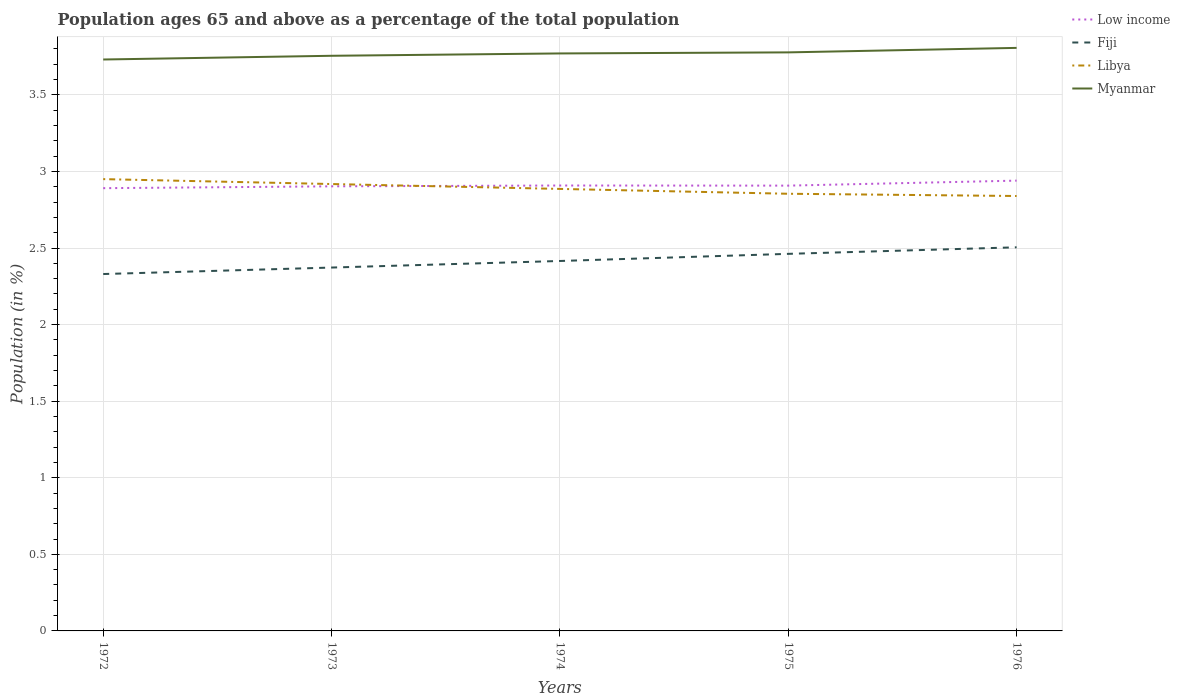How many different coloured lines are there?
Provide a short and direct response. 4. Is the number of lines equal to the number of legend labels?
Offer a terse response. Yes. Across all years, what is the maximum percentage of the population ages 65 and above in Myanmar?
Make the answer very short. 3.73. In which year was the percentage of the population ages 65 and above in Low income maximum?
Offer a very short reply. 1972. What is the total percentage of the population ages 65 and above in Myanmar in the graph?
Your answer should be compact. -0.02. What is the difference between the highest and the second highest percentage of the population ages 65 and above in Low income?
Give a very brief answer. 0.05. Is the percentage of the population ages 65 and above in Libya strictly greater than the percentage of the population ages 65 and above in Myanmar over the years?
Offer a very short reply. Yes. How many lines are there?
Give a very brief answer. 4. What is the difference between two consecutive major ticks on the Y-axis?
Provide a succinct answer. 0.5. Where does the legend appear in the graph?
Your response must be concise. Top right. How are the legend labels stacked?
Provide a short and direct response. Vertical. What is the title of the graph?
Provide a succinct answer. Population ages 65 and above as a percentage of the total population. What is the label or title of the Y-axis?
Offer a very short reply. Population (in %). What is the Population (in %) of Low income in 1972?
Give a very brief answer. 2.89. What is the Population (in %) in Fiji in 1972?
Provide a short and direct response. 2.33. What is the Population (in %) of Libya in 1972?
Offer a terse response. 2.95. What is the Population (in %) of Myanmar in 1972?
Your answer should be compact. 3.73. What is the Population (in %) in Low income in 1973?
Offer a very short reply. 2.9. What is the Population (in %) of Fiji in 1973?
Your response must be concise. 2.37. What is the Population (in %) of Libya in 1973?
Offer a very short reply. 2.92. What is the Population (in %) of Myanmar in 1973?
Provide a succinct answer. 3.76. What is the Population (in %) in Low income in 1974?
Ensure brevity in your answer.  2.91. What is the Population (in %) in Fiji in 1974?
Your answer should be compact. 2.42. What is the Population (in %) of Libya in 1974?
Your response must be concise. 2.89. What is the Population (in %) in Myanmar in 1974?
Offer a terse response. 3.77. What is the Population (in %) in Low income in 1975?
Provide a succinct answer. 2.91. What is the Population (in %) in Fiji in 1975?
Offer a very short reply. 2.46. What is the Population (in %) of Libya in 1975?
Provide a short and direct response. 2.85. What is the Population (in %) in Myanmar in 1975?
Keep it short and to the point. 3.78. What is the Population (in %) in Low income in 1976?
Offer a very short reply. 2.94. What is the Population (in %) in Fiji in 1976?
Your response must be concise. 2.5. What is the Population (in %) in Libya in 1976?
Provide a short and direct response. 2.84. What is the Population (in %) in Myanmar in 1976?
Offer a terse response. 3.81. Across all years, what is the maximum Population (in %) in Low income?
Your answer should be compact. 2.94. Across all years, what is the maximum Population (in %) of Fiji?
Offer a terse response. 2.5. Across all years, what is the maximum Population (in %) of Libya?
Give a very brief answer. 2.95. Across all years, what is the maximum Population (in %) of Myanmar?
Your answer should be compact. 3.81. Across all years, what is the minimum Population (in %) in Low income?
Provide a short and direct response. 2.89. Across all years, what is the minimum Population (in %) in Fiji?
Make the answer very short. 2.33. Across all years, what is the minimum Population (in %) in Libya?
Your answer should be compact. 2.84. Across all years, what is the minimum Population (in %) in Myanmar?
Give a very brief answer. 3.73. What is the total Population (in %) of Low income in the graph?
Make the answer very short. 14.55. What is the total Population (in %) of Fiji in the graph?
Your answer should be very brief. 12.09. What is the total Population (in %) of Libya in the graph?
Give a very brief answer. 14.45. What is the total Population (in %) of Myanmar in the graph?
Provide a short and direct response. 18.84. What is the difference between the Population (in %) in Low income in 1972 and that in 1973?
Offer a terse response. -0.01. What is the difference between the Population (in %) of Fiji in 1972 and that in 1973?
Your answer should be very brief. -0.04. What is the difference between the Population (in %) of Libya in 1972 and that in 1973?
Provide a succinct answer. 0.03. What is the difference between the Population (in %) in Myanmar in 1972 and that in 1973?
Your answer should be very brief. -0.02. What is the difference between the Population (in %) in Low income in 1972 and that in 1974?
Your answer should be compact. -0.02. What is the difference between the Population (in %) in Fiji in 1972 and that in 1974?
Offer a very short reply. -0.09. What is the difference between the Population (in %) of Libya in 1972 and that in 1974?
Make the answer very short. 0.06. What is the difference between the Population (in %) in Myanmar in 1972 and that in 1974?
Your answer should be very brief. -0.04. What is the difference between the Population (in %) in Low income in 1972 and that in 1975?
Your answer should be very brief. -0.02. What is the difference between the Population (in %) in Fiji in 1972 and that in 1975?
Keep it short and to the point. -0.13. What is the difference between the Population (in %) in Libya in 1972 and that in 1975?
Offer a terse response. 0.1. What is the difference between the Population (in %) of Myanmar in 1972 and that in 1975?
Your answer should be very brief. -0.05. What is the difference between the Population (in %) of Low income in 1972 and that in 1976?
Your response must be concise. -0.05. What is the difference between the Population (in %) in Fiji in 1972 and that in 1976?
Your answer should be very brief. -0.17. What is the difference between the Population (in %) of Libya in 1972 and that in 1976?
Provide a succinct answer. 0.11. What is the difference between the Population (in %) in Myanmar in 1972 and that in 1976?
Offer a terse response. -0.08. What is the difference between the Population (in %) of Low income in 1973 and that in 1974?
Make the answer very short. -0.01. What is the difference between the Population (in %) of Fiji in 1973 and that in 1974?
Your response must be concise. -0.04. What is the difference between the Population (in %) in Libya in 1973 and that in 1974?
Offer a very short reply. 0.03. What is the difference between the Population (in %) in Myanmar in 1973 and that in 1974?
Offer a very short reply. -0.02. What is the difference between the Population (in %) in Low income in 1973 and that in 1975?
Offer a very short reply. -0. What is the difference between the Population (in %) in Fiji in 1973 and that in 1975?
Provide a short and direct response. -0.09. What is the difference between the Population (in %) in Libya in 1973 and that in 1975?
Your answer should be compact. 0.06. What is the difference between the Population (in %) in Myanmar in 1973 and that in 1975?
Provide a short and direct response. -0.02. What is the difference between the Population (in %) of Low income in 1973 and that in 1976?
Your answer should be very brief. -0.04. What is the difference between the Population (in %) in Fiji in 1973 and that in 1976?
Your answer should be compact. -0.13. What is the difference between the Population (in %) of Libya in 1973 and that in 1976?
Keep it short and to the point. 0.08. What is the difference between the Population (in %) of Myanmar in 1973 and that in 1976?
Your response must be concise. -0.05. What is the difference between the Population (in %) in Low income in 1974 and that in 1975?
Your answer should be compact. 0. What is the difference between the Population (in %) of Fiji in 1974 and that in 1975?
Provide a short and direct response. -0.05. What is the difference between the Population (in %) in Libya in 1974 and that in 1975?
Provide a short and direct response. 0.03. What is the difference between the Population (in %) in Myanmar in 1974 and that in 1975?
Give a very brief answer. -0.01. What is the difference between the Population (in %) of Low income in 1974 and that in 1976?
Provide a short and direct response. -0.03. What is the difference between the Population (in %) in Fiji in 1974 and that in 1976?
Your answer should be compact. -0.09. What is the difference between the Population (in %) of Libya in 1974 and that in 1976?
Provide a short and direct response. 0.05. What is the difference between the Population (in %) in Myanmar in 1974 and that in 1976?
Your answer should be very brief. -0.04. What is the difference between the Population (in %) of Low income in 1975 and that in 1976?
Offer a terse response. -0.03. What is the difference between the Population (in %) of Fiji in 1975 and that in 1976?
Offer a very short reply. -0.04. What is the difference between the Population (in %) of Libya in 1975 and that in 1976?
Your answer should be very brief. 0.01. What is the difference between the Population (in %) in Myanmar in 1975 and that in 1976?
Your answer should be compact. -0.03. What is the difference between the Population (in %) in Low income in 1972 and the Population (in %) in Fiji in 1973?
Your answer should be very brief. 0.52. What is the difference between the Population (in %) of Low income in 1972 and the Population (in %) of Libya in 1973?
Make the answer very short. -0.03. What is the difference between the Population (in %) in Low income in 1972 and the Population (in %) in Myanmar in 1973?
Give a very brief answer. -0.86. What is the difference between the Population (in %) of Fiji in 1972 and the Population (in %) of Libya in 1973?
Offer a very short reply. -0.59. What is the difference between the Population (in %) in Fiji in 1972 and the Population (in %) in Myanmar in 1973?
Ensure brevity in your answer.  -1.43. What is the difference between the Population (in %) in Libya in 1972 and the Population (in %) in Myanmar in 1973?
Give a very brief answer. -0.81. What is the difference between the Population (in %) of Low income in 1972 and the Population (in %) of Fiji in 1974?
Your answer should be very brief. 0.48. What is the difference between the Population (in %) of Low income in 1972 and the Population (in %) of Libya in 1974?
Make the answer very short. 0. What is the difference between the Population (in %) in Low income in 1972 and the Population (in %) in Myanmar in 1974?
Provide a succinct answer. -0.88. What is the difference between the Population (in %) in Fiji in 1972 and the Population (in %) in Libya in 1974?
Your response must be concise. -0.56. What is the difference between the Population (in %) in Fiji in 1972 and the Population (in %) in Myanmar in 1974?
Your answer should be very brief. -1.44. What is the difference between the Population (in %) in Libya in 1972 and the Population (in %) in Myanmar in 1974?
Ensure brevity in your answer.  -0.82. What is the difference between the Population (in %) in Low income in 1972 and the Population (in %) in Fiji in 1975?
Offer a very short reply. 0.43. What is the difference between the Population (in %) in Low income in 1972 and the Population (in %) in Libya in 1975?
Your answer should be very brief. 0.04. What is the difference between the Population (in %) in Low income in 1972 and the Population (in %) in Myanmar in 1975?
Your response must be concise. -0.89. What is the difference between the Population (in %) in Fiji in 1972 and the Population (in %) in Libya in 1975?
Provide a succinct answer. -0.52. What is the difference between the Population (in %) in Fiji in 1972 and the Population (in %) in Myanmar in 1975?
Provide a succinct answer. -1.45. What is the difference between the Population (in %) of Libya in 1972 and the Population (in %) of Myanmar in 1975?
Keep it short and to the point. -0.83. What is the difference between the Population (in %) of Low income in 1972 and the Population (in %) of Fiji in 1976?
Provide a succinct answer. 0.39. What is the difference between the Population (in %) of Low income in 1972 and the Population (in %) of Libya in 1976?
Keep it short and to the point. 0.05. What is the difference between the Population (in %) of Low income in 1972 and the Population (in %) of Myanmar in 1976?
Your response must be concise. -0.92. What is the difference between the Population (in %) in Fiji in 1972 and the Population (in %) in Libya in 1976?
Your answer should be compact. -0.51. What is the difference between the Population (in %) in Fiji in 1972 and the Population (in %) in Myanmar in 1976?
Offer a terse response. -1.48. What is the difference between the Population (in %) in Libya in 1972 and the Population (in %) in Myanmar in 1976?
Your response must be concise. -0.86. What is the difference between the Population (in %) in Low income in 1973 and the Population (in %) in Fiji in 1974?
Make the answer very short. 0.49. What is the difference between the Population (in %) of Low income in 1973 and the Population (in %) of Libya in 1974?
Provide a short and direct response. 0.02. What is the difference between the Population (in %) of Low income in 1973 and the Population (in %) of Myanmar in 1974?
Offer a very short reply. -0.87. What is the difference between the Population (in %) in Fiji in 1973 and the Population (in %) in Libya in 1974?
Your answer should be very brief. -0.51. What is the difference between the Population (in %) in Fiji in 1973 and the Population (in %) in Myanmar in 1974?
Provide a succinct answer. -1.4. What is the difference between the Population (in %) of Libya in 1973 and the Population (in %) of Myanmar in 1974?
Provide a succinct answer. -0.85. What is the difference between the Population (in %) of Low income in 1973 and the Population (in %) of Fiji in 1975?
Provide a succinct answer. 0.44. What is the difference between the Population (in %) in Low income in 1973 and the Population (in %) in Libya in 1975?
Your answer should be compact. 0.05. What is the difference between the Population (in %) of Low income in 1973 and the Population (in %) of Myanmar in 1975?
Provide a succinct answer. -0.87. What is the difference between the Population (in %) of Fiji in 1973 and the Population (in %) of Libya in 1975?
Offer a terse response. -0.48. What is the difference between the Population (in %) of Fiji in 1973 and the Population (in %) of Myanmar in 1975?
Give a very brief answer. -1.41. What is the difference between the Population (in %) of Libya in 1973 and the Population (in %) of Myanmar in 1975?
Your response must be concise. -0.86. What is the difference between the Population (in %) of Low income in 1973 and the Population (in %) of Fiji in 1976?
Keep it short and to the point. 0.4. What is the difference between the Population (in %) of Low income in 1973 and the Population (in %) of Libya in 1976?
Your response must be concise. 0.06. What is the difference between the Population (in %) of Low income in 1973 and the Population (in %) of Myanmar in 1976?
Offer a terse response. -0.9. What is the difference between the Population (in %) in Fiji in 1973 and the Population (in %) in Libya in 1976?
Make the answer very short. -0.47. What is the difference between the Population (in %) in Fiji in 1973 and the Population (in %) in Myanmar in 1976?
Your answer should be very brief. -1.43. What is the difference between the Population (in %) in Libya in 1973 and the Population (in %) in Myanmar in 1976?
Keep it short and to the point. -0.89. What is the difference between the Population (in %) of Low income in 1974 and the Population (in %) of Fiji in 1975?
Make the answer very short. 0.45. What is the difference between the Population (in %) in Low income in 1974 and the Population (in %) in Libya in 1975?
Provide a succinct answer. 0.05. What is the difference between the Population (in %) of Low income in 1974 and the Population (in %) of Myanmar in 1975?
Your answer should be very brief. -0.87. What is the difference between the Population (in %) in Fiji in 1974 and the Population (in %) in Libya in 1975?
Provide a short and direct response. -0.44. What is the difference between the Population (in %) of Fiji in 1974 and the Population (in %) of Myanmar in 1975?
Ensure brevity in your answer.  -1.36. What is the difference between the Population (in %) of Libya in 1974 and the Population (in %) of Myanmar in 1975?
Your answer should be very brief. -0.89. What is the difference between the Population (in %) of Low income in 1974 and the Population (in %) of Fiji in 1976?
Give a very brief answer. 0.4. What is the difference between the Population (in %) of Low income in 1974 and the Population (in %) of Libya in 1976?
Your response must be concise. 0.07. What is the difference between the Population (in %) of Low income in 1974 and the Population (in %) of Myanmar in 1976?
Offer a terse response. -0.9. What is the difference between the Population (in %) in Fiji in 1974 and the Population (in %) in Libya in 1976?
Offer a very short reply. -0.42. What is the difference between the Population (in %) of Fiji in 1974 and the Population (in %) of Myanmar in 1976?
Offer a terse response. -1.39. What is the difference between the Population (in %) of Libya in 1974 and the Population (in %) of Myanmar in 1976?
Give a very brief answer. -0.92. What is the difference between the Population (in %) of Low income in 1975 and the Population (in %) of Fiji in 1976?
Offer a very short reply. 0.4. What is the difference between the Population (in %) in Low income in 1975 and the Population (in %) in Libya in 1976?
Give a very brief answer. 0.07. What is the difference between the Population (in %) in Low income in 1975 and the Population (in %) in Myanmar in 1976?
Provide a short and direct response. -0.9. What is the difference between the Population (in %) in Fiji in 1975 and the Population (in %) in Libya in 1976?
Your answer should be compact. -0.38. What is the difference between the Population (in %) of Fiji in 1975 and the Population (in %) of Myanmar in 1976?
Make the answer very short. -1.34. What is the difference between the Population (in %) of Libya in 1975 and the Population (in %) of Myanmar in 1976?
Your response must be concise. -0.95. What is the average Population (in %) in Low income per year?
Offer a terse response. 2.91. What is the average Population (in %) in Fiji per year?
Provide a short and direct response. 2.42. What is the average Population (in %) of Libya per year?
Your answer should be compact. 2.89. What is the average Population (in %) in Myanmar per year?
Give a very brief answer. 3.77. In the year 1972, what is the difference between the Population (in %) in Low income and Population (in %) in Fiji?
Keep it short and to the point. 0.56. In the year 1972, what is the difference between the Population (in %) of Low income and Population (in %) of Libya?
Provide a succinct answer. -0.06. In the year 1972, what is the difference between the Population (in %) in Low income and Population (in %) in Myanmar?
Offer a very short reply. -0.84. In the year 1972, what is the difference between the Population (in %) of Fiji and Population (in %) of Libya?
Keep it short and to the point. -0.62. In the year 1972, what is the difference between the Population (in %) of Fiji and Population (in %) of Myanmar?
Your answer should be compact. -1.4. In the year 1972, what is the difference between the Population (in %) of Libya and Population (in %) of Myanmar?
Your answer should be very brief. -0.78. In the year 1973, what is the difference between the Population (in %) of Low income and Population (in %) of Fiji?
Ensure brevity in your answer.  0.53. In the year 1973, what is the difference between the Population (in %) in Low income and Population (in %) in Libya?
Your answer should be very brief. -0.01. In the year 1973, what is the difference between the Population (in %) of Low income and Population (in %) of Myanmar?
Ensure brevity in your answer.  -0.85. In the year 1973, what is the difference between the Population (in %) in Fiji and Population (in %) in Libya?
Your answer should be very brief. -0.55. In the year 1973, what is the difference between the Population (in %) of Fiji and Population (in %) of Myanmar?
Ensure brevity in your answer.  -1.38. In the year 1973, what is the difference between the Population (in %) of Libya and Population (in %) of Myanmar?
Ensure brevity in your answer.  -0.84. In the year 1974, what is the difference between the Population (in %) of Low income and Population (in %) of Fiji?
Provide a short and direct response. 0.49. In the year 1974, what is the difference between the Population (in %) of Low income and Population (in %) of Libya?
Give a very brief answer. 0.02. In the year 1974, what is the difference between the Population (in %) in Low income and Population (in %) in Myanmar?
Offer a terse response. -0.86. In the year 1974, what is the difference between the Population (in %) of Fiji and Population (in %) of Libya?
Give a very brief answer. -0.47. In the year 1974, what is the difference between the Population (in %) in Fiji and Population (in %) in Myanmar?
Ensure brevity in your answer.  -1.36. In the year 1974, what is the difference between the Population (in %) of Libya and Population (in %) of Myanmar?
Make the answer very short. -0.88. In the year 1975, what is the difference between the Population (in %) in Low income and Population (in %) in Fiji?
Give a very brief answer. 0.45. In the year 1975, what is the difference between the Population (in %) in Low income and Population (in %) in Libya?
Offer a terse response. 0.05. In the year 1975, what is the difference between the Population (in %) in Low income and Population (in %) in Myanmar?
Provide a short and direct response. -0.87. In the year 1975, what is the difference between the Population (in %) of Fiji and Population (in %) of Libya?
Give a very brief answer. -0.39. In the year 1975, what is the difference between the Population (in %) in Fiji and Population (in %) in Myanmar?
Offer a terse response. -1.32. In the year 1975, what is the difference between the Population (in %) in Libya and Population (in %) in Myanmar?
Your answer should be compact. -0.92. In the year 1976, what is the difference between the Population (in %) in Low income and Population (in %) in Fiji?
Provide a short and direct response. 0.44. In the year 1976, what is the difference between the Population (in %) of Low income and Population (in %) of Libya?
Keep it short and to the point. 0.1. In the year 1976, what is the difference between the Population (in %) of Low income and Population (in %) of Myanmar?
Give a very brief answer. -0.87. In the year 1976, what is the difference between the Population (in %) of Fiji and Population (in %) of Libya?
Give a very brief answer. -0.34. In the year 1976, what is the difference between the Population (in %) of Fiji and Population (in %) of Myanmar?
Offer a very short reply. -1.3. In the year 1976, what is the difference between the Population (in %) in Libya and Population (in %) in Myanmar?
Ensure brevity in your answer.  -0.97. What is the ratio of the Population (in %) in Low income in 1972 to that in 1973?
Ensure brevity in your answer.  1. What is the ratio of the Population (in %) in Fiji in 1972 to that in 1973?
Give a very brief answer. 0.98. What is the ratio of the Population (in %) of Myanmar in 1972 to that in 1973?
Provide a short and direct response. 0.99. What is the ratio of the Population (in %) of Low income in 1972 to that in 1974?
Provide a succinct answer. 0.99. What is the ratio of the Population (in %) of Fiji in 1972 to that in 1974?
Give a very brief answer. 0.96. What is the ratio of the Population (in %) of Libya in 1972 to that in 1974?
Ensure brevity in your answer.  1.02. What is the ratio of the Population (in %) of Myanmar in 1972 to that in 1974?
Provide a short and direct response. 0.99. What is the ratio of the Population (in %) in Fiji in 1972 to that in 1975?
Your response must be concise. 0.95. What is the ratio of the Population (in %) in Libya in 1972 to that in 1975?
Keep it short and to the point. 1.03. What is the ratio of the Population (in %) in Myanmar in 1972 to that in 1975?
Give a very brief answer. 0.99. What is the ratio of the Population (in %) of Low income in 1972 to that in 1976?
Your response must be concise. 0.98. What is the ratio of the Population (in %) of Fiji in 1972 to that in 1976?
Keep it short and to the point. 0.93. What is the ratio of the Population (in %) in Libya in 1972 to that in 1976?
Your answer should be very brief. 1.04. What is the ratio of the Population (in %) of Myanmar in 1972 to that in 1976?
Your response must be concise. 0.98. What is the ratio of the Population (in %) in Low income in 1973 to that in 1974?
Ensure brevity in your answer.  1. What is the ratio of the Population (in %) in Fiji in 1973 to that in 1974?
Your answer should be compact. 0.98. What is the ratio of the Population (in %) in Libya in 1973 to that in 1974?
Keep it short and to the point. 1.01. What is the ratio of the Population (in %) of Myanmar in 1973 to that in 1974?
Keep it short and to the point. 1. What is the ratio of the Population (in %) in Low income in 1973 to that in 1975?
Make the answer very short. 1. What is the ratio of the Population (in %) in Fiji in 1973 to that in 1975?
Your answer should be very brief. 0.96. What is the ratio of the Population (in %) in Libya in 1973 to that in 1975?
Your answer should be very brief. 1.02. What is the ratio of the Population (in %) of Myanmar in 1973 to that in 1975?
Offer a terse response. 0.99. What is the ratio of the Population (in %) in Low income in 1973 to that in 1976?
Your answer should be very brief. 0.99. What is the ratio of the Population (in %) in Fiji in 1973 to that in 1976?
Provide a short and direct response. 0.95. What is the ratio of the Population (in %) of Libya in 1973 to that in 1976?
Your response must be concise. 1.03. What is the ratio of the Population (in %) of Myanmar in 1973 to that in 1976?
Provide a succinct answer. 0.99. What is the ratio of the Population (in %) in Fiji in 1974 to that in 1975?
Provide a succinct answer. 0.98. What is the ratio of the Population (in %) in Libya in 1974 to that in 1975?
Provide a succinct answer. 1.01. What is the ratio of the Population (in %) in Myanmar in 1974 to that in 1975?
Ensure brevity in your answer.  1. What is the ratio of the Population (in %) of Fiji in 1974 to that in 1976?
Ensure brevity in your answer.  0.96. What is the ratio of the Population (in %) in Libya in 1974 to that in 1976?
Give a very brief answer. 1.02. What is the ratio of the Population (in %) in Myanmar in 1974 to that in 1976?
Provide a succinct answer. 0.99. What is the ratio of the Population (in %) in Low income in 1975 to that in 1976?
Provide a succinct answer. 0.99. What is the ratio of the Population (in %) of Myanmar in 1975 to that in 1976?
Offer a terse response. 0.99. What is the difference between the highest and the second highest Population (in %) in Low income?
Your answer should be very brief. 0.03. What is the difference between the highest and the second highest Population (in %) in Fiji?
Provide a succinct answer. 0.04. What is the difference between the highest and the second highest Population (in %) in Libya?
Offer a terse response. 0.03. What is the difference between the highest and the second highest Population (in %) of Myanmar?
Your answer should be very brief. 0.03. What is the difference between the highest and the lowest Population (in %) of Low income?
Your answer should be compact. 0.05. What is the difference between the highest and the lowest Population (in %) of Fiji?
Offer a terse response. 0.17. What is the difference between the highest and the lowest Population (in %) in Libya?
Your answer should be compact. 0.11. What is the difference between the highest and the lowest Population (in %) of Myanmar?
Offer a very short reply. 0.08. 